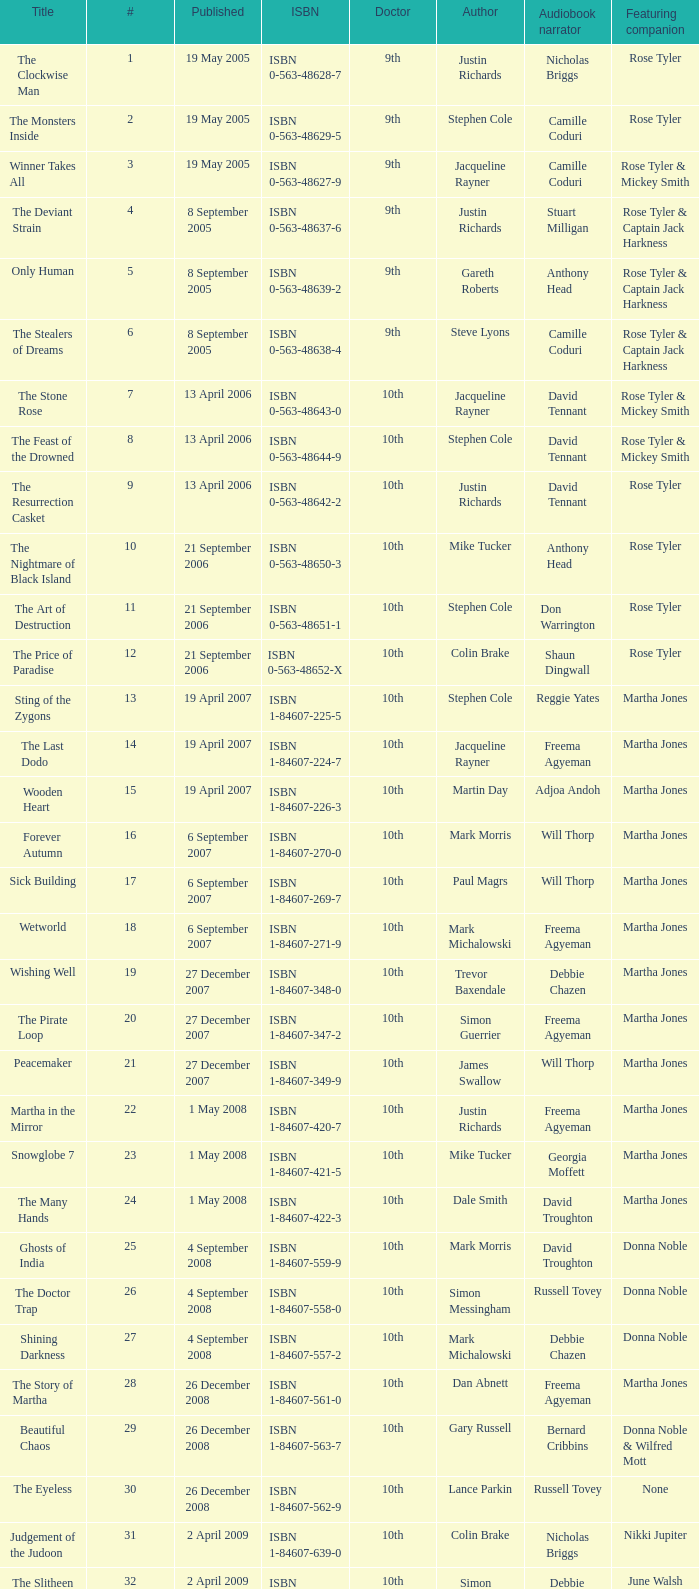Who are the featuring companions of number 3? Rose Tyler & Mickey Smith. 